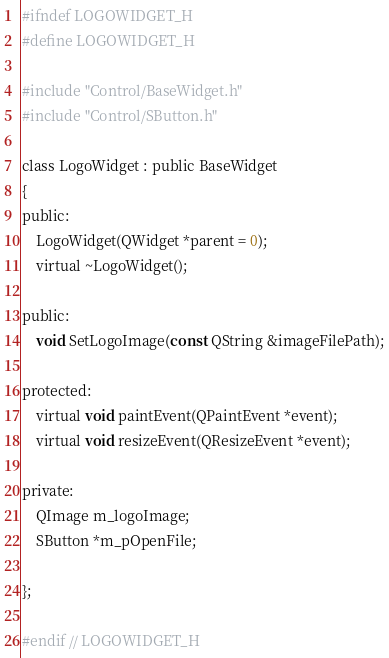Convert code to text. <code><loc_0><loc_0><loc_500><loc_500><_C_>#ifndef LOGOWIDGET_H
#define LOGOWIDGET_H

#include "Control/BaseWidget.h"
#include "Control/SButton.h"

class LogoWidget : public BaseWidget
{
public:
    LogoWidget(QWidget *parent = 0);
    virtual ~LogoWidget();

public:
    void SetLogoImage(const QString &imageFilePath);

protected:
    virtual void paintEvent(QPaintEvent *event);
    virtual void resizeEvent(QResizeEvent *event);

private:
    QImage m_logoImage;
    SButton *m_pOpenFile;

};

#endif // LOGOWIDGET_H
</code> 